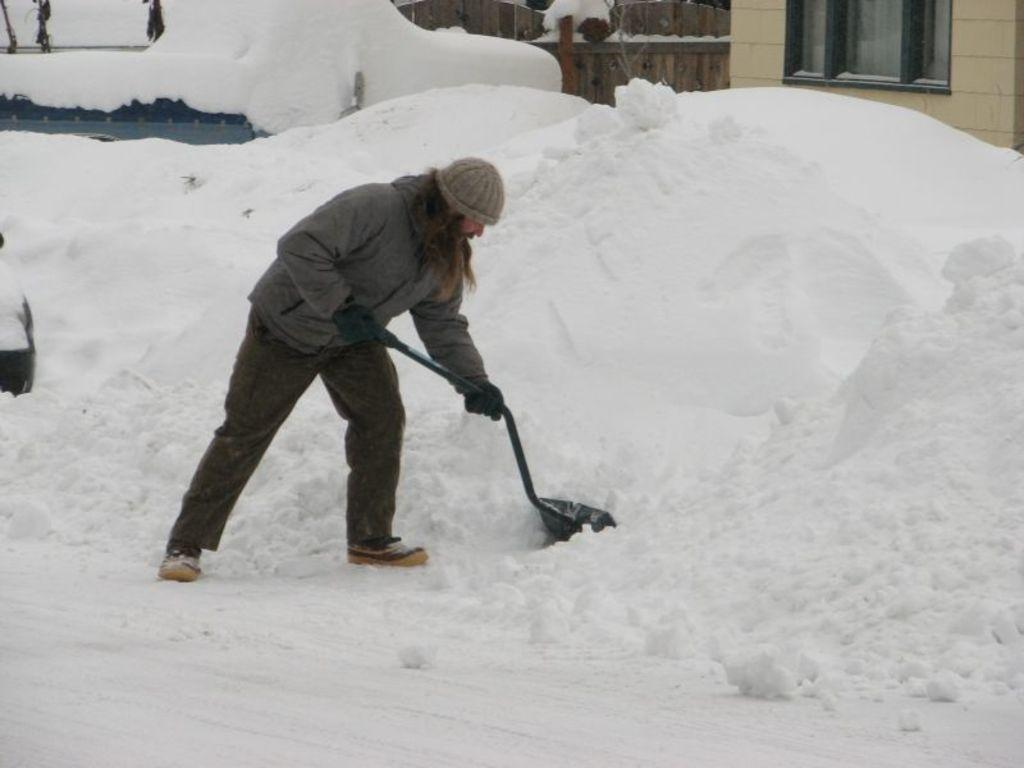Who is present in the image? There is a person in the image. What is the person holding in his hand? The person is holding a spade in his hand. What is the weather like in the image? There is snow visible in the image, indicating a cold and snowy environment. What can be seen in the background of the image? There is a building in the background of the image. What type of pets does the person have in the image? There is no indication of any pets in the image. What is the person learning in the image? There is no indication of any learning activity in the image. 